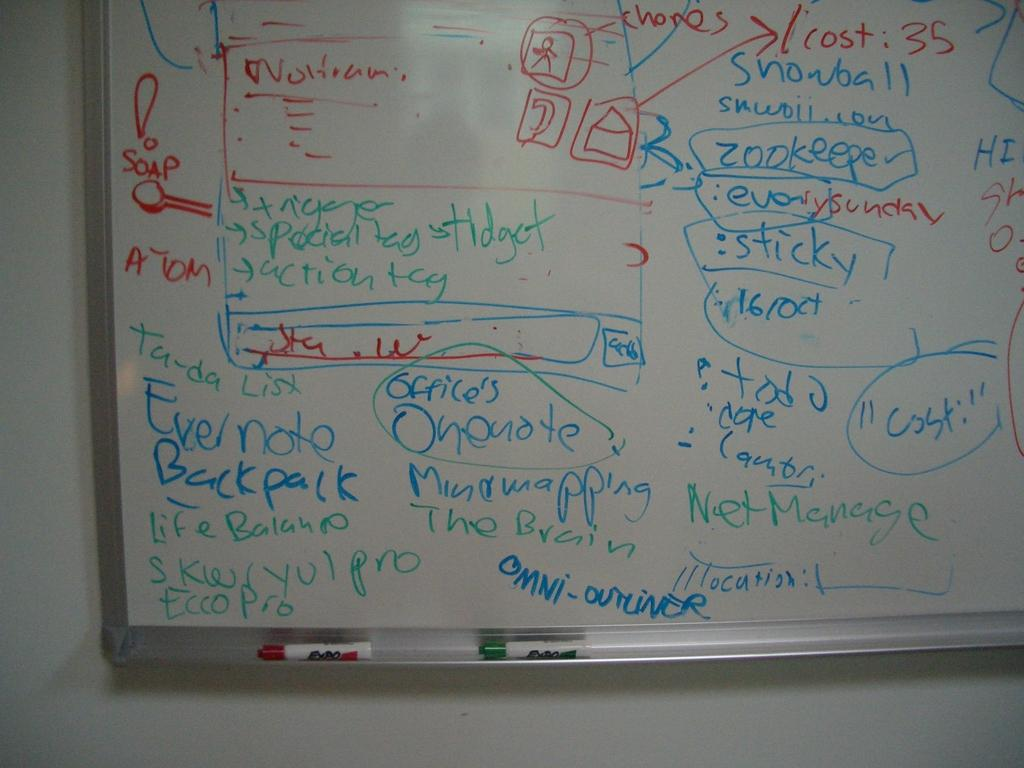<image>
Give a short and clear explanation of the subsequent image. Someone has written the word "soap" in red letters on the left side of the board. 